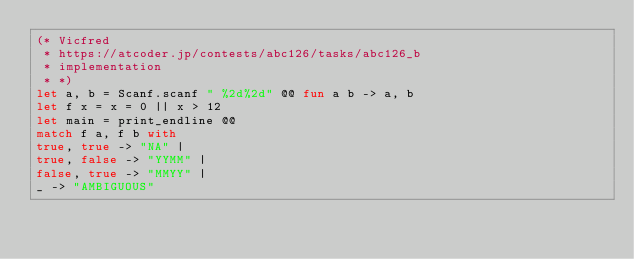Convert code to text. <code><loc_0><loc_0><loc_500><loc_500><_OCaml_>(* Vicfred
 * https://atcoder.jp/contests/abc126/tasks/abc126_b
 * implementation
 * *)
let a, b = Scanf.scanf " %2d%2d" @@ fun a b -> a, b
let f x = x = 0 || x > 12
let main = print_endline @@
match f a, f b with
true, true -> "NA" |
true, false -> "YYMM" |
false, true -> "MMYY" |
_ -> "AMBIGUOUS"

</code> 